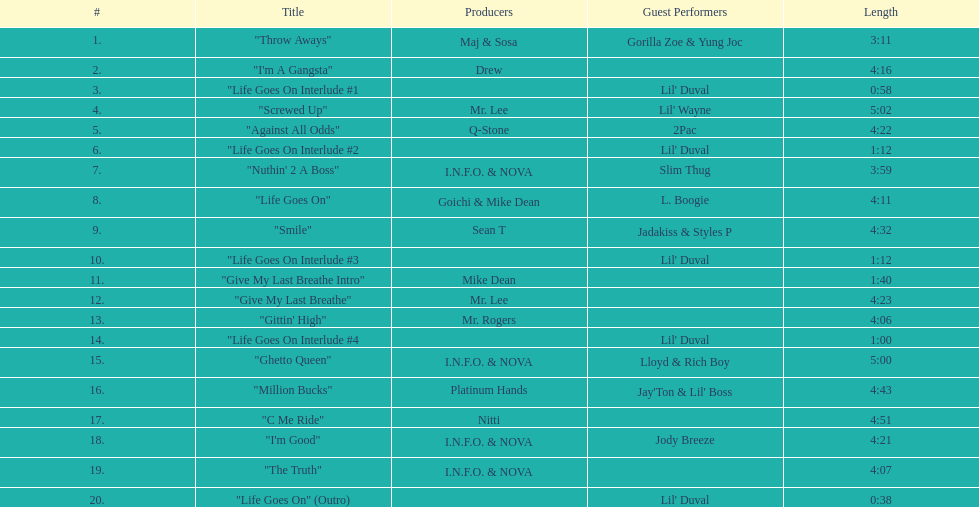What is the most extended track on the album? "Screwed Up". 